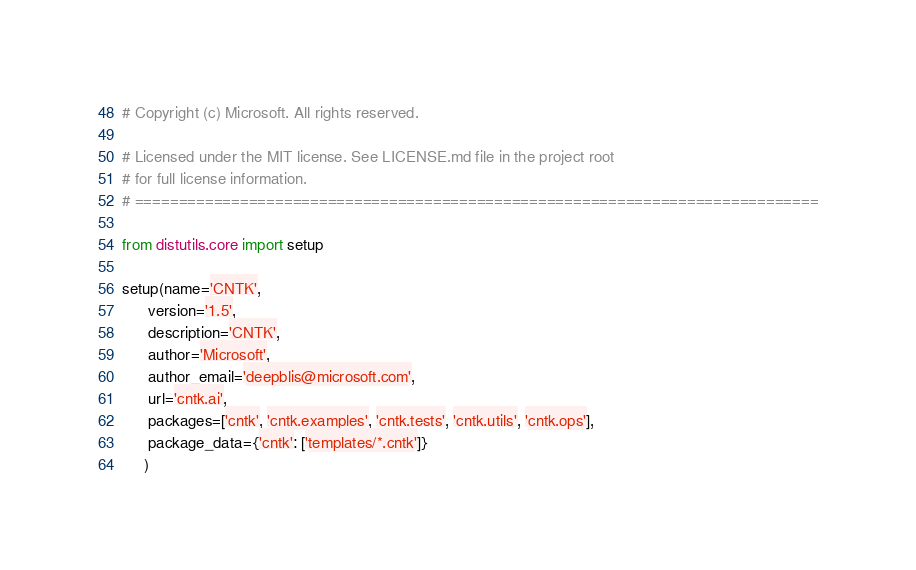Convert code to text. <code><loc_0><loc_0><loc_500><loc_500><_Python_># Copyright (c) Microsoft. All rights reserved.

# Licensed under the MIT license. See LICENSE.md file in the project root 
# for full license information.
# ==============================================================================

from distutils.core import setup

setup(name='CNTK',
      version='1.5',
      description='CNTK',
      author='Microsoft',
      author_email='deepblis@microsoft.com',
      url='cntk.ai',
      packages=['cntk', 'cntk.examples', 'cntk.tests', 'cntk.utils', 'cntk.ops'],
      package_data={'cntk': ['templates/*.cntk']}
     )
</code> 